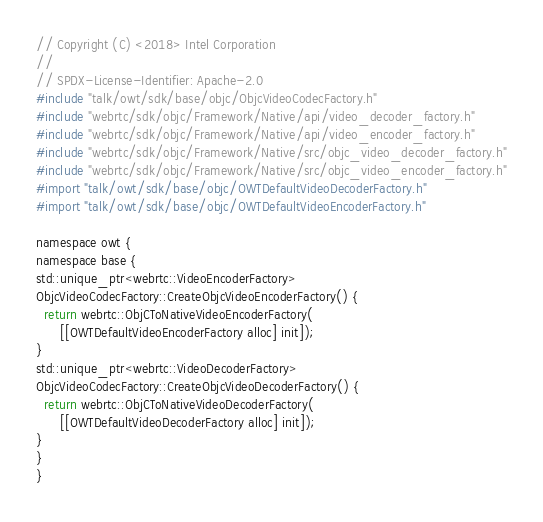Convert code to text. <code><loc_0><loc_0><loc_500><loc_500><_ObjectiveC_>// Copyright (C) <2018> Intel Corporation
//
// SPDX-License-Identifier: Apache-2.0
#include "talk/owt/sdk/base/objc/ObjcVideoCodecFactory.h"
#include "webrtc/sdk/objc/Framework/Native/api/video_decoder_factory.h"
#include "webrtc/sdk/objc/Framework/Native/api/video_encoder_factory.h"
#include "webrtc/sdk/objc/Framework/Native/src/objc_video_decoder_factory.h"
#include "webrtc/sdk/objc/Framework/Native/src/objc_video_encoder_factory.h"
#import "talk/owt/sdk/base/objc/OWTDefaultVideoDecoderFactory.h"
#import "talk/owt/sdk/base/objc/OWTDefaultVideoEncoderFactory.h"

namespace owt {
namespace base {
std::unique_ptr<webrtc::VideoEncoderFactory>
ObjcVideoCodecFactory::CreateObjcVideoEncoderFactory() {
  return webrtc::ObjCToNativeVideoEncoderFactory(
      [[OWTDefaultVideoEncoderFactory alloc] init]);
}
std::unique_ptr<webrtc::VideoDecoderFactory>
ObjcVideoCodecFactory::CreateObjcVideoDecoderFactory() {
  return webrtc::ObjCToNativeVideoDecoderFactory(
      [[OWTDefaultVideoDecoderFactory alloc] init]);
}
}
}
</code> 